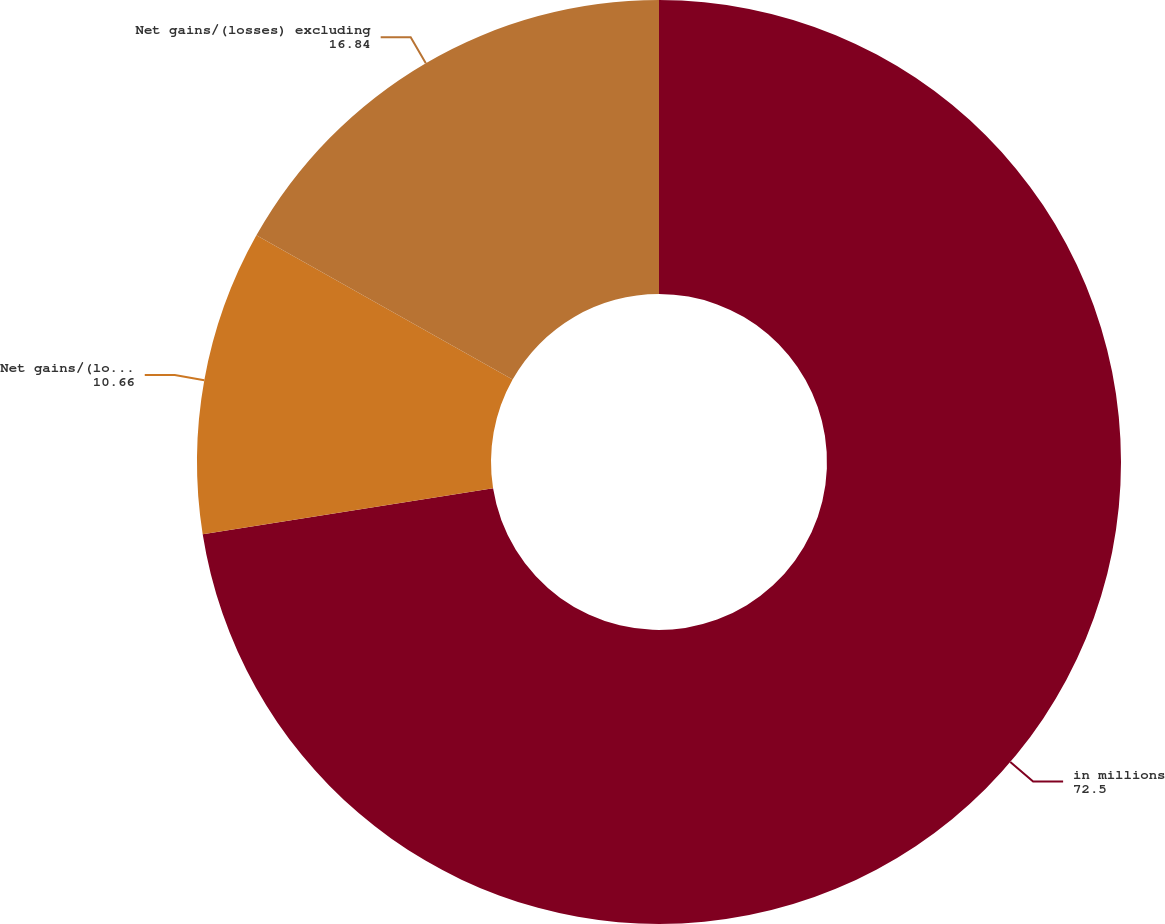Convert chart. <chart><loc_0><loc_0><loc_500><loc_500><pie_chart><fcel>in millions<fcel>Net gains/(losses) including<fcel>Net gains/(losses) excluding<nl><fcel>72.5%<fcel>10.66%<fcel>16.84%<nl></chart> 